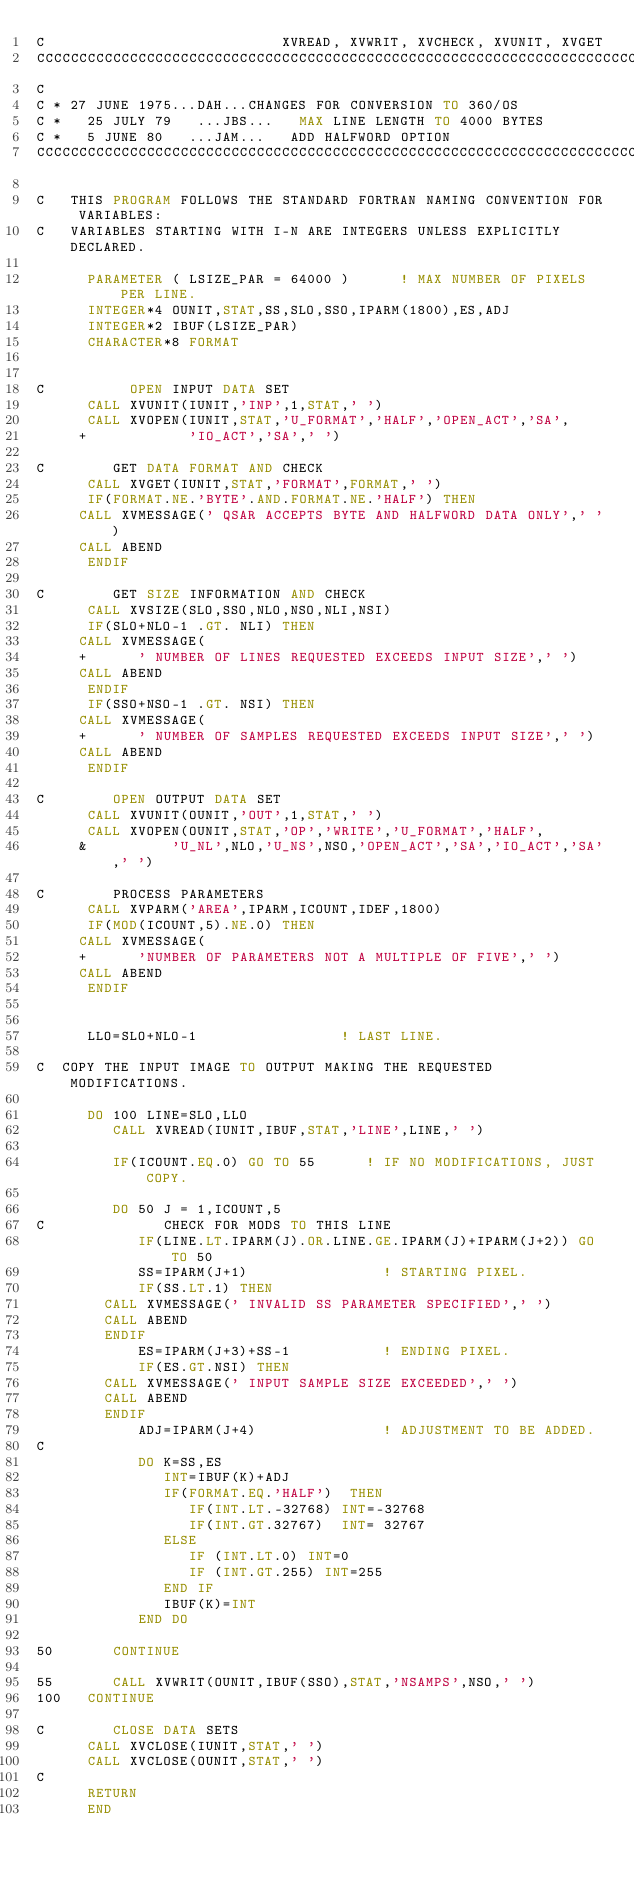Convert code to text. <code><loc_0><loc_0><loc_500><loc_500><_FORTRAN_>C                            XVREAD, XVWRIT, XVCHECK, XVUNIT, XVGET
CCCCCCCCCCCCCCCCCCCCCCCCCCCCCCCCCCCCCCCCCCCCCCCCCCCCCCCCCCCCCCCCCCCCCCCCCC
C
C * 27 JUNE 1975...DAH...CHANGES FOR CONVERSION TO 360/OS
C *   25 JULY 79   ...JBS...   MAX LINE LENGTH TO 4000 BYTES
C *   5 JUNE 80   ...JAM...   ADD HALFWORD OPTION
CCCCCCCCCCCCCCCCCCCCCCCCCCCCCCCCCCCCCCCCCCCCCCCCCCCCCCCCCCCCCCCCCCCCCCCCCCC

C   THIS PROGRAM FOLLOWS THE STANDARD FORTRAN NAMING CONVENTION FOR VARIABLES:
C   VARIABLES STARTING WITH I-N ARE INTEGERS UNLESS EXPLICITLY DECLARED.

      PARAMETER ( LSIZE_PAR = 64000 )      ! MAX NUMBER OF PIXELS PER LINE.
      INTEGER*4 OUNIT,STAT,SS,SLO,SSO,IPARM(1800),ES,ADJ
      INTEGER*2 IBUF(LSIZE_PAR)
      CHARACTER*8 FORMAT


C          OPEN INPUT DATA SET
      CALL XVUNIT(IUNIT,'INP',1,STAT,' ')
      CALL XVOPEN(IUNIT,STAT,'U_FORMAT','HALF','OPEN_ACT','SA',
     +            'IO_ACT','SA',' ')

C        GET DATA FORMAT AND CHECK
      CALL XVGET(IUNIT,STAT,'FORMAT',FORMAT,' ')
      IF(FORMAT.NE.'BYTE'.AND.FORMAT.NE.'HALF') THEN
	 CALL XVMESSAGE(' QSAR ACCEPTS BYTE AND HALFWORD DATA ONLY',' ')
	 CALL ABEND
      ENDIF

C        GET SIZE INFORMATION AND CHECK
      CALL XVSIZE(SLO,SSO,NLO,NSO,NLI,NSI)
      IF(SLO+NLO-1 .GT. NLI) THEN
	 CALL XVMESSAGE(
     +		' NUMBER OF LINES REQUESTED EXCEEDS INPUT SIZE',' ')
	 CALL ABEND
      ENDIF
      IF(SSO+NSO-1 .GT. NSI) THEN
	 CALL XVMESSAGE(
     +		' NUMBER OF SAMPLES REQUESTED EXCEEDS INPUT SIZE',' ')
	 CALL ABEND
      ENDIF

C        OPEN OUTPUT DATA SET
      CALL XVUNIT(OUNIT,'OUT',1,STAT,' ')
      CALL XVOPEN(OUNIT,STAT,'OP','WRITE','U_FORMAT','HALF',
     &          'U_NL',NLO,'U_NS',NSO,'OPEN_ACT','SA','IO_ACT','SA',' ')

C        PROCESS PARAMETERS
      CALL XVPARM('AREA',IPARM,ICOUNT,IDEF,1800)
      IF(MOD(ICOUNT,5).NE.0) THEN
	 CALL XVMESSAGE(
     +		'NUMBER OF PARAMETERS NOT A MULTIPLE OF FIVE',' ')
	 CALL ABEND
      ENDIF


      LLO=SLO+NLO-1                 ! LAST LINE.

C  COPY THE INPUT IMAGE TO OUTPUT MAKING THE REQUESTED MODIFICATIONS.

      DO 100 LINE=SLO,LLO
         CALL XVREAD(IUNIT,IBUF,STAT,'LINE',LINE,' ')

         IF(ICOUNT.EQ.0) GO TO 55      ! IF NO MODIFICATIONS, JUST COPY.

         DO 50 J = 1,ICOUNT,5
C              CHECK FOR MODS TO THIS LINE
            IF(LINE.LT.IPARM(J).OR.LINE.GE.IPARM(J)+IPARM(J+2)) GO TO 50
            SS=IPARM(J+1)                ! STARTING PIXEL.
            IF(SS.LT.1) THEN
		CALL XVMESSAGE(' INVALID SS PARAMETER SPECIFIED',' ')
		CALL ABEND
	    ENDIF
            ES=IPARM(J+3)+SS-1           ! ENDING PIXEL.
            IF(ES.GT.NSI) THEN
		CALL XVMESSAGE(' INPUT SAMPLE SIZE EXCEEDED',' ')
		CALL ABEND
	    ENDIF
            ADJ=IPARM(J+4)               ! ADJUSTMENT TO BE ADDED.
C 
            DO K=SS,ES
               INT=IBUF(K)+ADJ
               IF(FORMAT.EQ.'HALF')  THEN 
                  IF(INT.LT.-32768) INT=-32768
                  IF(INT.GT.32767)  INT= 32767
               ELSE 
                  IF (INT.LT.0) INT=0
                  IF (INT.GT.255) INT=255
               END IF 
               IBUF(K)=INT
            END DO

50       CONTINUE

55       CALL XVWRIT(OUNIT,IBUF(SSO),STAT,'NSAMPS',NSO,' ')
100   CONTINUE

C        CLOSE DATA SETS
      CALL XVCLOSE(IUNIT,STAT,' ')
      CALL XVCLOSE(OUNIT,STAT,' ')
C
      RETURN        
      END
</code> 